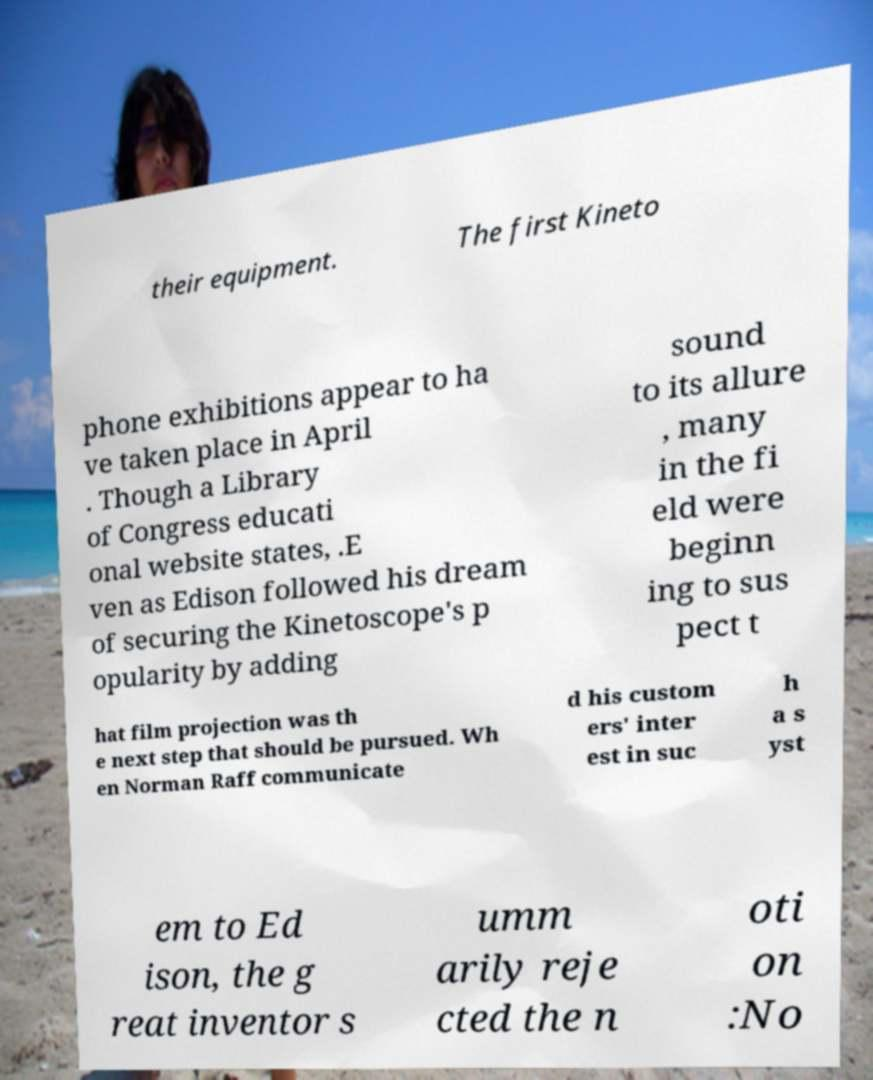For documentation purposes, I need the text within this image transcribed. Could you provide that? their equipment. The first Kineto phone exhibitions appear to ha ve taken place in April . Though a Library of Congress educati onal website states, .E ven as Edison followed his dream of securing the Kinetoscope's p opularity by adding sound to its allure , many in the fi eld were beginn ing to sus pect t hat film projection was th e next step that should be pursued. Wh en Norman Raff communicate d his custom ers' inter est in suc h a s yst em to Ed ison, the g reat inventor s umm arily reje cted the n oti on :No 